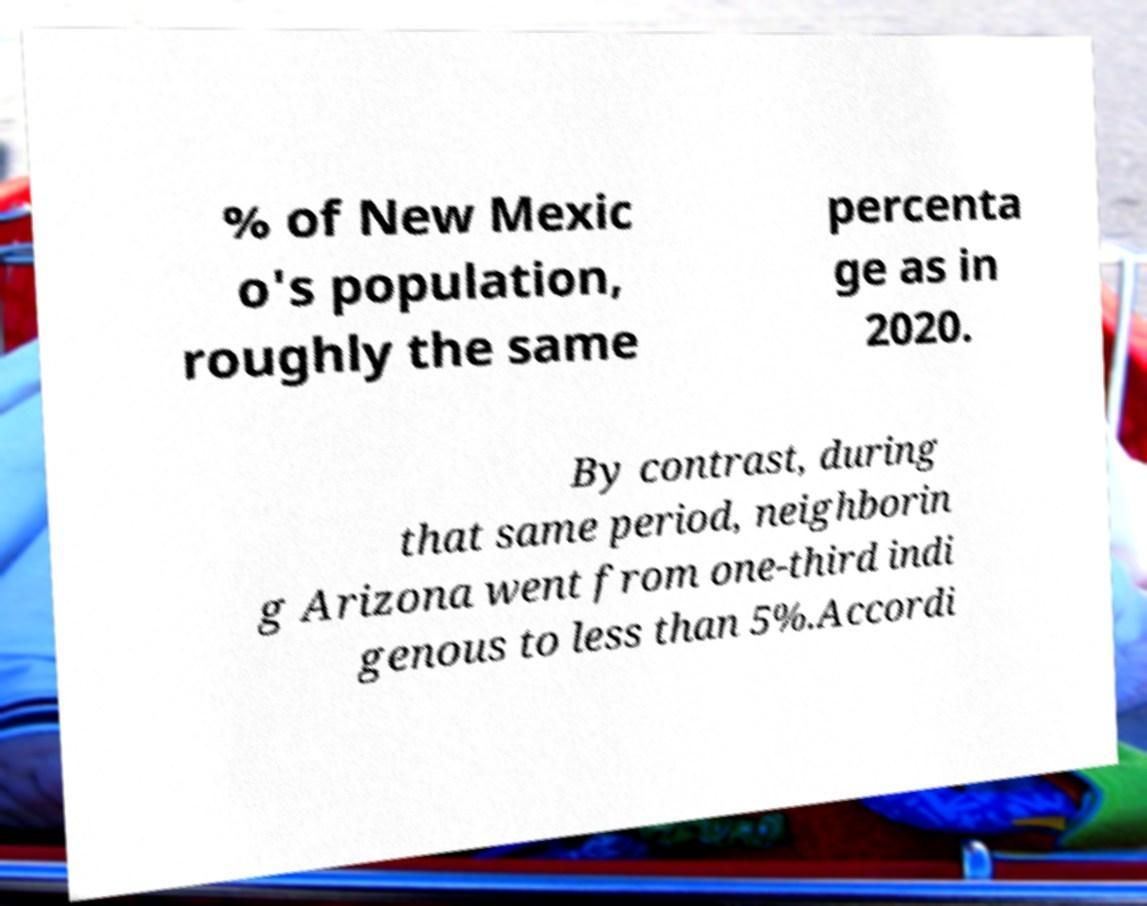For documentation purposes, I need the text within this image transcribed. Could you provide that? % of New Mexic o's population, roughly the same percenta ge as in 2020. By contrast, during that same period, neighborin g Arizona went from one-third indi genous to less than 5%.Accordi 